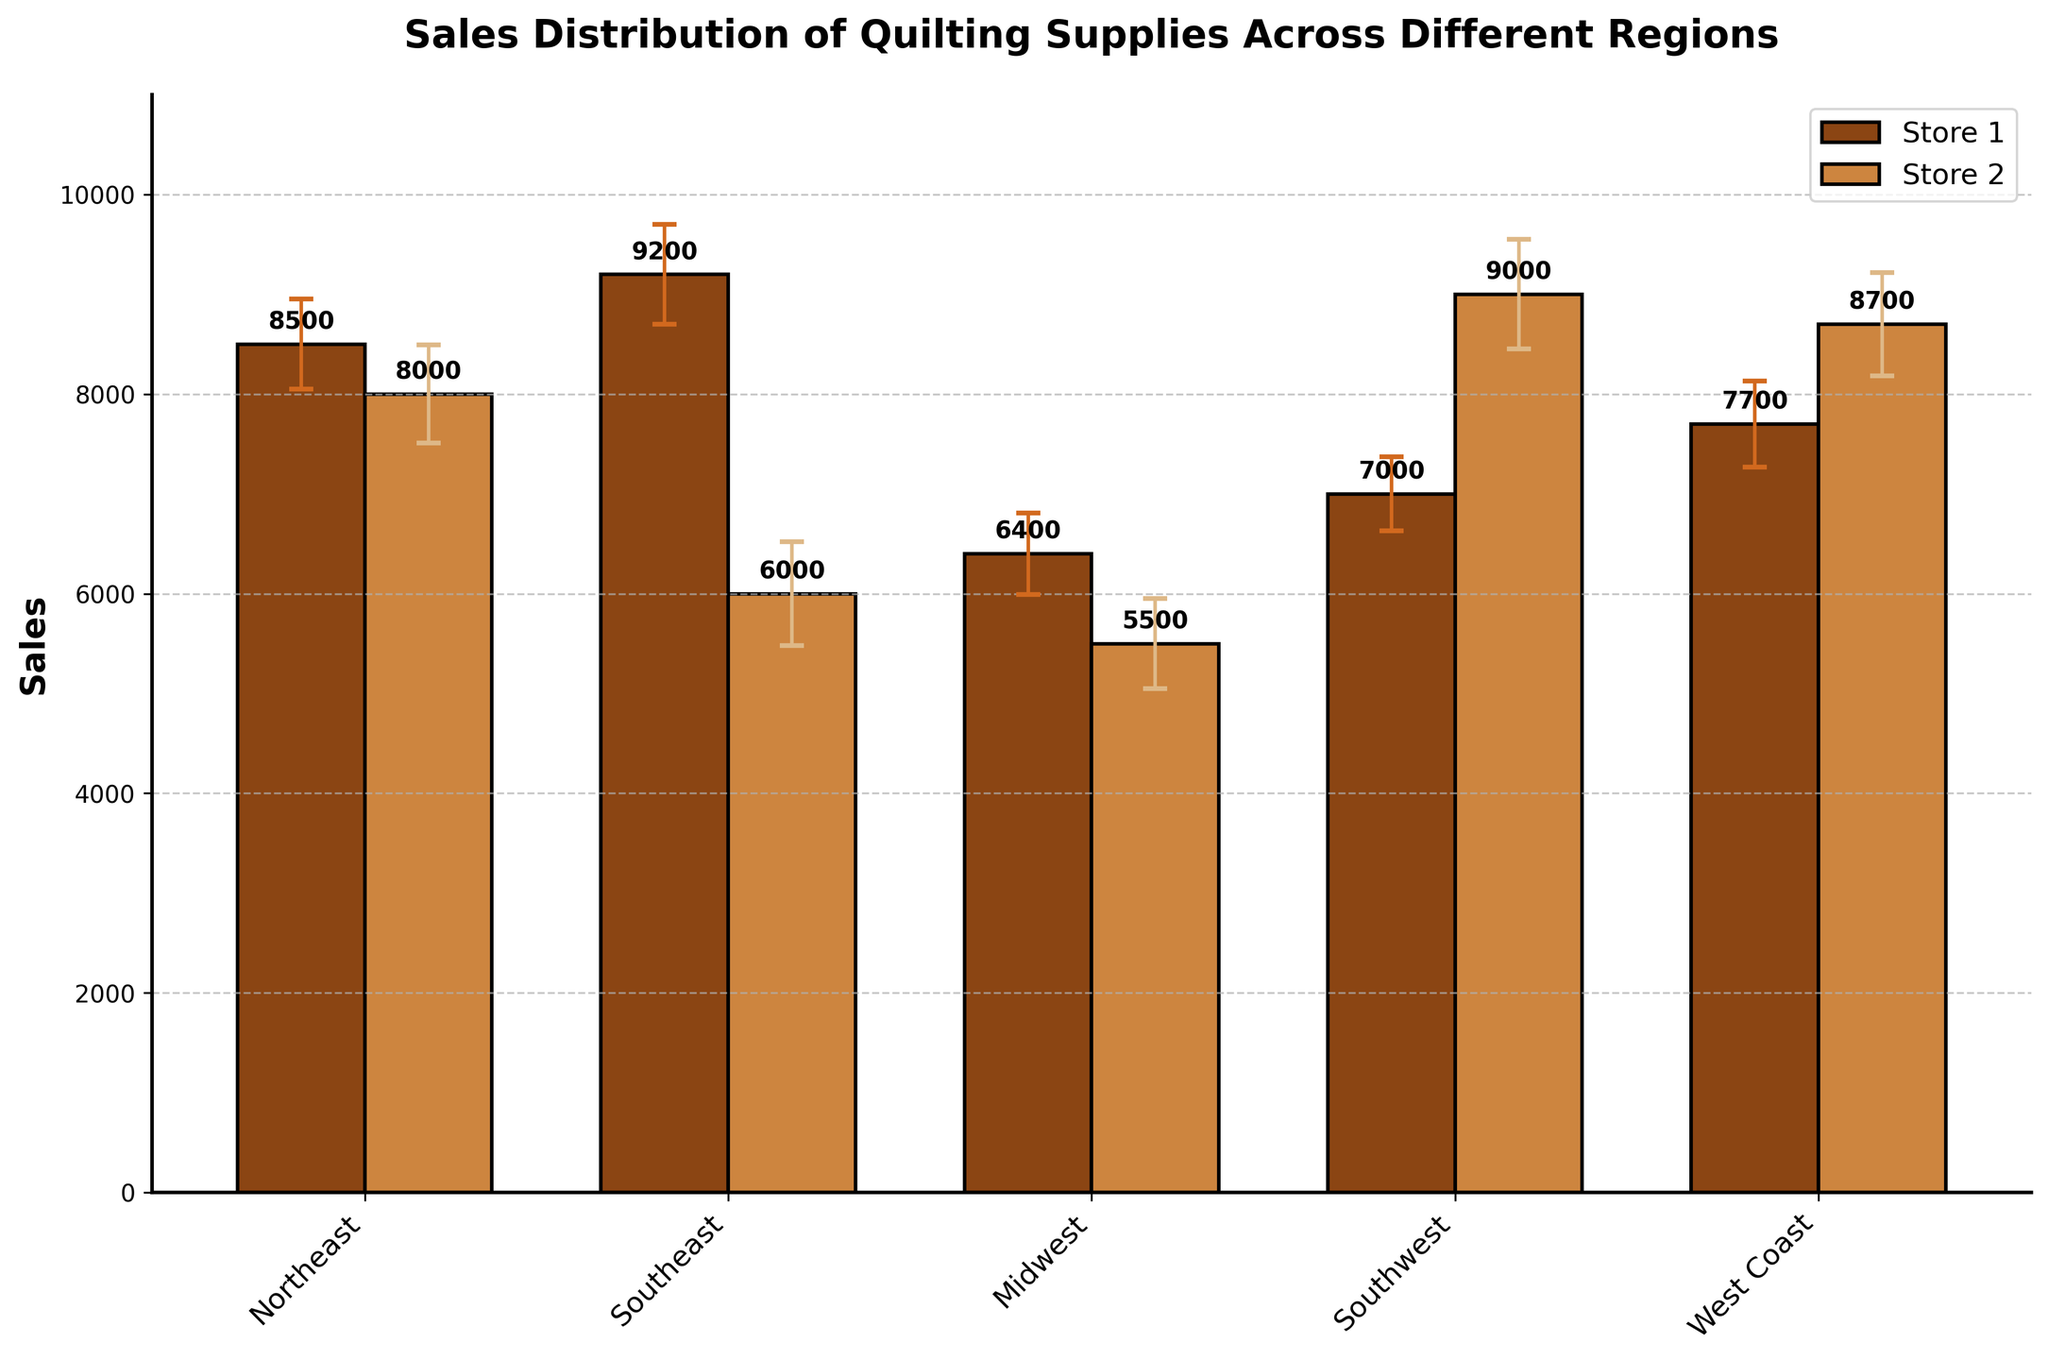What's the title of the bar chart? The title of the bar chart is displayed at the top center and provides the primary information about the chart's content.
Answer: Sales Distribution of Quilting Supplies Across Different Regions Which region has the highest average sales? By looking at the height of the bars, the West Coast region has the highest sales bars, indicating the highest average sales.
Answer: West Coast What is the sales value for Quilt Haven in the Northeast? Identifying the specific bar associated with Quilt Haven in the Northeast, the sales value is shown as labeled near the top of the bar.
Answer: 8500 Which store has the largest error bar in the West Coast region? By observing the error bars in the West Coast region, Pacific Quilts has the largest error bar.
Answer: Pacific Quilts What is the difference in sales between Southern Stitches and Gentle Threads in the Southeast? Southern Stitches has sales of 6400 and Gentle Threads has sales of 7000. The difference is calculated as 7000 - 6400.
Answer: 600 Compare the sales of Heartland Fabrics and Quilter's Paradise. Which one has higher sales and by how much? Heartland Fabrics has sales of 7700, and Quilter's Paradise has sales of 8000. Quilter's Paradise has higher sales, with a difference of 8000 - 7700.
Answer: Quilter's Paradise by 300 What is the combined sales value of the stores in the Midwest region? Summing up the sales associated with the Midwest region: 7700 + 8000 = 15700.
Answer: 15700 What is the standard deviation for Desert Quilts in the Southwest region? The standard deviation for Desert Quilts is indicated alongside the sales value and error bar, which is 520.
Answer: 520 Which region has the lowest sales for any store, and what is the sales value? By observing the smallest bar, the Southwest region has the lowest sales for Cactus Quilters, which is 5500.
Answer: Southwest, 5500 For the Northeast region, calculate the average sales across both stores. The sales are 8500 for Quilt Haven and 9200 for Pine Tree Quilts. The average is (8500 + 9200) / 2.
Answer: 8850 